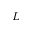Convert formula to latex. <formula><loc_0><loc_0><loc_500><loc_500>L</formula> 